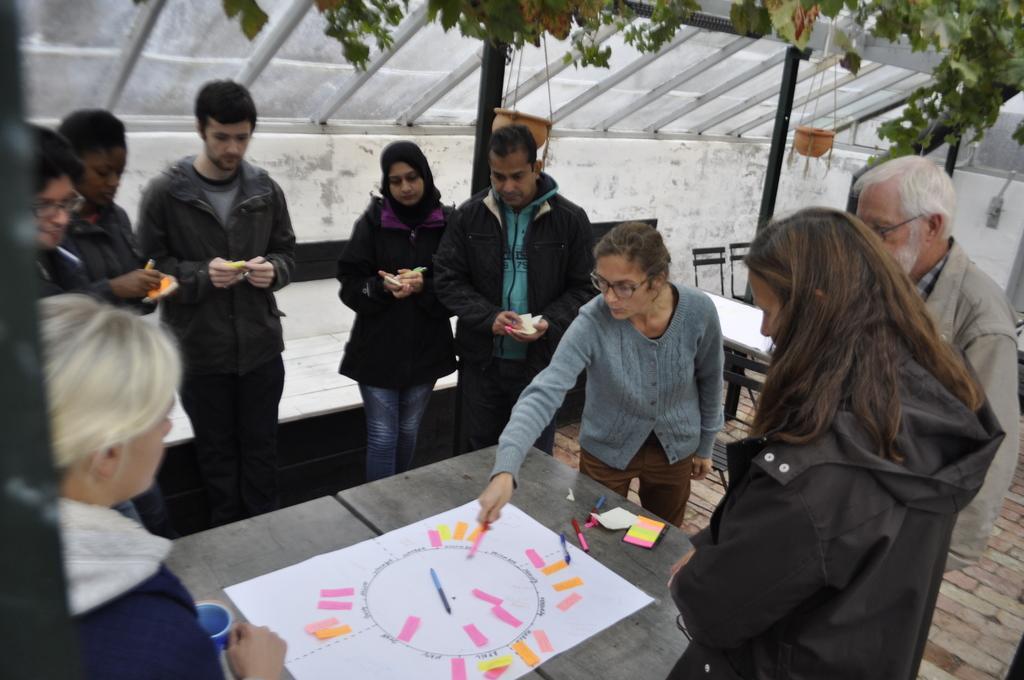Could you give a brief overview of what you see in this image? In this image i can see few people standing around the table, On the table i can see a sheet, pan and few pieces of papers. In the background i can see flower pot and plant. 